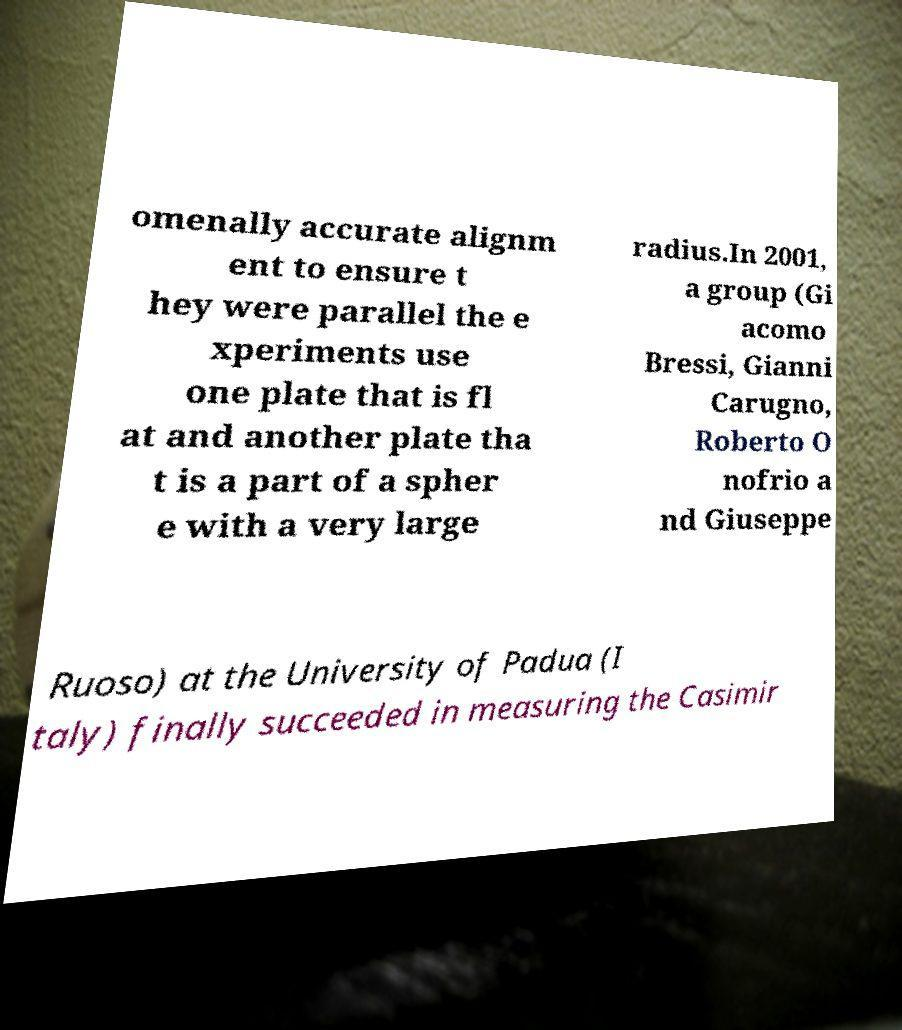What messages or text are displayed in this image? I need them in a readable, typed format. omenally accurate alignm ent to ensure t hey were parallel the e xperiments use one plate that is fl at and another plate tha t is a part of a spher e with a very large radius.In 2001, a group (Gi acomo Bressi, Gianni Carugno, Roberto O nofrio a nd Giuseppe Ruoso) at the University of Padua (I taly) finally succeeded in measuring the Casimir 